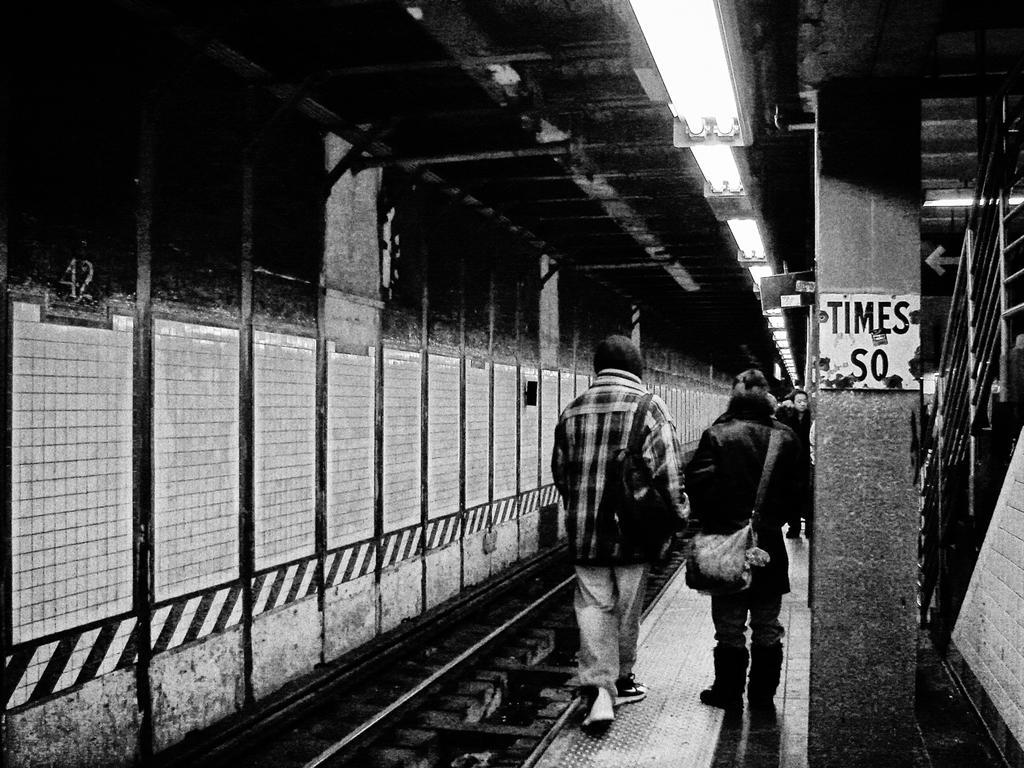Please provide a concise description of this image. In this picture we can observe some people walking on the platform. We can observe a railway track on the left side. There is a pillar and we can observe some text on the pillar. This is a black and white image. 